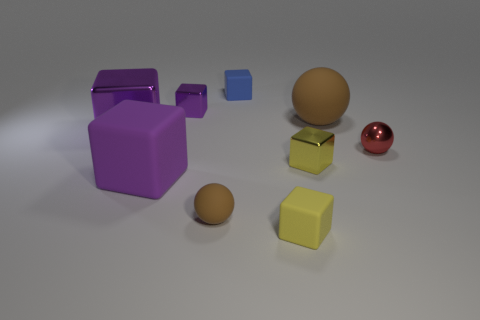What might be the function of the shapes with drawers? While the shapes with drawers resemble storage units, given the setting and their stylistic rendering, they might be purely decorative here. If this image reflects a practical setting, these shapes could function as organizers or compartments for small items. 